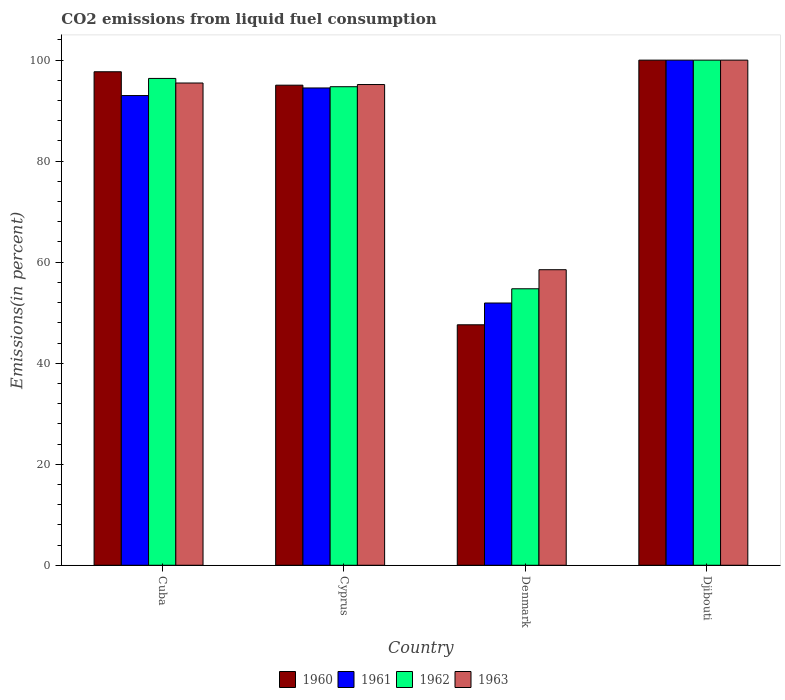How many different coloured bars are there?
Make the answer very short. 4. Are the number of bars on each tick of the X-axis equal?
Keep it short and to the point. Yes. How many bars are there on the 4th tick from the left?
Offer a very short reply. 4. How many bars are there on the 3rd tick from the right?
Your answer should be very brief. 4. What is the label of the 4th group of bars from the left?
Provide a succinct answer. Djibouti. Across all countries, what is the minimum total CO2 emitted in 1961?
Give a very brief answer. 51.92. In which country was the total CO2 emitted in 1961 maximum?
Offer a terse response. Djibouti. What is the total total CO2 emitted in 1960 in the graph?
Ensure brevity in your answer.  340.34. What is the difference between the total CO2 emitted in 1961 in Cyprus and that in Djibouti?
Give a very brief answer. -5.51. What is the difference between the total CO2 emitted in 1961 in Denmark and the total CO2 emitted in 1960 in Cuba?
Give a very brief answer. -45.78. What is the average total CO2 emitted in 1961 per country?
Offer a very short reply. 84.85. What is the difference between the total CO2 emitted of/in 1960 and total CO2 emitted of/in 1961 in Denmark?
Give a very brief answer. -4.31. In how many countries, is the total CO2 emitted in 1960 greater than 48 %?
Your answer should be compact. 3. What is the ratio of the total CO2 emitted in 1961 in Cuba to that in Djibouti?
Your answer should be compact. 0.93. Is the total CO2 emitted in 1963 in Cyprus less than that in Denmark?
Offer a very short reply. No. Is the difference between the total CO2 emitted in 1960 in Cyprus and Denmark greater than the difference between the total CO2 emitted in 1961 in Cyprus and Denmark?
Provide a short and direct response. Yes. What is the difference between the highest and the second highest total CO2 emitted in 1960?
Keep it short and to the point. -2.3. What is the difference between the highest and the lowest total CO2 emitted in 1962?
Offer a terse response. 45.26. Is it the case that in every country, the sum of the total CO2 emitted in 1960 and total CO2 emitted in 1963 is greater than the sum of total CO2 emitted in 1961 and total CO2 emitted in 1962?
Your response must be concise. No. What does the 1st bar from the left in Cyprus represents?
Provide a short and direct response. 1960. Is it the case that in every country, the sum of the total CO2 emitted in 1960 and total CO2 emitted in 1962 is greater than the total CO2 emitted in 1961?
Your answer should be compact. Yes. How many bars are there?
Provide a short and direct response. 16. How many countries are there in the graph?
Ensure brevity in your answer.  4. Are the values on the major ticks of Y-axis written in scientific E-notation?
Offer a very short reply. No. Does the graph contain grids?
Provide a short and direct response. No. Where does the legend appear in the graph?
Ensure brevity in your answer.  Bottom center. How many legend labels are there?
Offer a terse response. 4. How are the legend labels stacked?
Offer a terse response. Horizontal. What is the title of the graph?
Keep it short and to the point. CO2 emissions from liquid fuel consumption. What is the label or title of the X-axis?
Keep it short and to the point. Country. What is the label or title of the Y-axis?
Provide a succinct answer. Emissions(in percent). What is the Emissions(in percent) in 1960 in Cuba?
Provide a short and direct response. 97.7. What is the Emissions(in percent) of 1961 in Cuba?
Your response must be concise. 92.99. What is the Emissions(in percent) of 1962 in Cuba?
Make the answer very short. 96.38. What is the Emissions(in percent) of 1963 in Cuba?
Make the answer very short. 95.47. What is the Emissions(in percent) of 1960 in Cyprus?
Provide a short and direct response. 95.04. What is the Emissions(in percent) of 1961 in Cyprus?
Your response must be concise. 94.49. What is the Emissions(in percent) of 1962 in Cyprus?
Your answer should be compact. 94.74. What is the Emissions(in percent) in 1963 in Cyprus?
Make the answer very short. 95.17. What is the Emissions(in percent) in 1960 in Denmark?
Provide a succinct answer. 47.6. What is the Emissions(in percent) of 1961 in Denmark?
Make the answer very short. 51.92. What is the Emissions(in percent) in 1962 in Denmark?
Provide a short and direct response. 54.74. What is the Emissions(in percent) in 1963 in Denmark?
Ensure brevity in your answer.  58.51. What is the Emissions(in percent) in 1961 in Djibouti?
Your answer should be compact. 100. What is the Emissions(in percent) in 1962 in Djibouti?
Offer a very short reply. 100. What is the Emissions(in percent) in 1963 in Djibouti?
Offer a terse response. 100. Across all countries, what is the maximum Emissions(in percent) of 1963?
Your answer should be compact. 100. Across all countries, what is the minimum Emissions(in percent) in 1960?
Provide a succinct answer. 47.6. Across all countries, what is the minimum Emissions(in percent) of 1961?
Offer a terse response. 51.92. Across all countries, what is the minimum Emissions(in percent) of 1962?
Your response must be concise. 54.74. Across all countries, what is the minimum Emissions(in percent) of 1963?
Your answer should be very brief. 58.51. What is the total Emissions(in percent) in 1960 in the graph?
Provide a short and direct response. 340.34. What is the total Emissions(in percent) in 1961 in the graph?
Ensure brevity in your answer.  339.4. What is the total Emissions(in percent) in 1962 in the graph?
Make the answer very short. 345.85. What is the total Emissions(in percent) in 1963 in the graph?
Your response must be concise. 349.15. What is the difference between the Emissions(in percent) of 1960 in Cuba and that in Cyprus?
Give a very brief answer. 2.66. What is the difference between the Emissions(in percent) of 1961 in Cuba and that in Cyprus?
Your answer should be compact. -1.51. What is the difference between the Emissions(in percent) of 1962 in Cuba and that in Cyprus?
Offer a terse response. 1.64. What is the difference between the Emissions(in percent) in 1963 in Cuba and that in Cyprus?
Provide a short and direct response. 0.31. What is the difference between the Emissions(in percent) of 1960 in Cuba and that in Denmark?
Make the answer very short. 50.09. What is the difference between the Emissions(in percent) of 1961 in Cuba and that in Denmark?
Give a very brief answer. 41.07. What is the difference between the Emissions(in percent) in 1962 in Cuba and that in Denmark?
Your response must be concise. 41.64. What is the difference between the Emissions(in percent) of 1963 in Cuba and that in Denmark?
Offer a terse response. 36.96. What is the difference between the Emissions(in percent) of 1960 in Cuba and that in Djibouti?
Keep it short and to the point. -2.3. What is the difference between the Emissions(in percent) of 1961 in Cuba and that in Djibouti?
Make the answer very short. -7.01. What is the difference between the Emissions(in percent) in 1962 in Cuba and that in Djibouti?
Offer a terse response. -3.62. What is the difference between the Emissions(in percent) of 1963 in Cuba and that in Djibouti?
Offer a very short reply. -4.53. What is the difference between the Emissions(in percent) in 1960 in Cyprus and that in Denmark?
Ensure brevity in your answer.  47.44. What is the difference between the Emissions(in percent) in 1961 in Cyprus and that in Denmark?
Keep it short and to the point. 42.57. What is the difference between the Emissions(in percent) in 1963 in Cyprus and that in Denmark?
Your answer should be very brief. 36.66. What is the difference between the Emissions(in percent) in 1960 in Cyprus and that in Djibouti?
Your answer should be very brief. -4.96. What is the difference between the Emissions(in percent) of 1961 in Cyprus and that in Djibouti?
Your answer should be compact. -5.51. What is the difference between the Emissions(in percent) in 1962 in Cyprus and that in Djibouti?
Offer a very short reply. -5.26. What is the difference between the Emissions(in percent) in 1963 in Cyprus and that in Djibouti?
Your answer should be compact. -4.83. What is the difference between the Emissions(in percent) in 1960 in Denmark and that in Djibouti?
Keep it short and to the point. -52.4. What is the difference between the Emissions(in percent) in 1961 in Denmark and that in Djibouti?
Offer a very short reply. -48.08. What is the difference between the Emissions(in percent) of 1962 in Denmark and that in Djibouti?
Your answer should be very brief. -45.26. What is the difference between the Emissions(in percent) of 1963 in Denmark and that in Djibouti?
Offer a very short reply. -41.49. What is the difference between the Emissions(in percent) of 1960 in Cuba and the Emissions(in percent) of 1961 in Cyprus?
Keep it short and to the point. 3.21. What is the difference between the Emissions(in percent) of 1960 in Cuba and the Emissions(in percent) of 1962 in Cyprus?
Your answer should be compact. 2.96. What is the difference between the Emissions(in percent) of 1960 in Cuba and the Emissions(in percent) of 1963 in Cyprus?
Make the answer very short. 2.53. What is the difference between the Emissions(in percent) in 1961 in Cuba and the Emissions(in percent) in 1962 in Cyprus?
Provide a short and direct response. -1.75. What is the difference between the Emissions(in percent) of 1961 in Cuba and the Emissions(in percent) of 1963 in Cyprus?
Make the answer very short. -2.18. What is the difference between the Emissions(in percent) of 1962 in Cuba and the Emissions(in percent) of 1963 in Cyprus?
Your response must be concise. 1.21. What is the difference between the Emissions(in percent) of 1960 in Cuba and the Emissions(in percent) of 1961 in Denmark?
Your answer should be compact. 45.78. What is the difference between the Emissions(in percent) in 1960 in Cuba and the Emissions(in percent) in 1962 in Denmark?
Ensure brevity in your answer.  42.96. What is the difference between the Emissions(in percent) in 1960 in Cuba and the Emissions(in percent) in 1963 in Denmark?
Your answer should be very brief. 39.19. What is the difference between the Emissions(in percent) of 1961 in Cuba and the Emissions(in percent) of 1962 in Denmark?
Offer a very short reply. 38.25. What is the difference between the Emissions(in percent) of 1961 in Cuba and the Emissions(in percent) of 1963 in Denmark?
Offer a very short reply. 34.48. What is the difference between the Emissions(in percent) in 1962 in Cuba and the Emissions(in percent) in 1963 in Denmark?
Provide a succinct answer. 37.87. What is the difference between the Emissions(in percent) of 1960 in Cuba and the Emissions(in percent) of 1961 in Djibouti?
Make the answer very short. -2.3. What is the difference between the Emissions(in percent) of 1960 in Cuba and the Emissions(in percent) of 1962 in Djibouti?
Make the answer very short. -2.3. What is the difference between the Emissions(in percent) of 1960 in Cuba and the Emissions(in percent) of 1963 in Djibouti?
Make the answer very short. -2.3. What is the difference between the Emissions(in percent) of 1961 in Cuba and the Emissions(in percent) of 1962 in Djibouti?
Provide a succinct answer. -7.01. What is the difference between the Emissions(in percent) of 1961 in Cuba and the Emissions(in percent) of 1963 in Djibouti?
Keep it short and to the point. -7.01. What is the difference between the Emissions(in percent) in 1962 in Cuba and the Emissions(in percent) in 1963 in Djibouti?
Make the answer very short. -3.62. What is the difference between the Emissions(in percent) in 1960 in Cyprus and the Emissions(in percent) in 1961 in Denmark?
Provide a short and direct response. 43.12. What is the difference between the Emissions(in percent) of 1960 in Cyprus and the Emissions(in percent) of 1962 in Denmark?
Keep it short and to the point. 40.3. What is the difference between the Emissions(in percent) in 1960 in Cyprus and the Emissions(in percent) in 1963 in Denmark?
Ensure brevity in your answer.  36.53. What is the difference between the Emissions(in percent) in 1961 in Cyprus and the Emissions(in percent) in 1962 in Denmark?
Provide a succinct answer. 39.75. What is the difference between the Emissions(in percent) in 1961 in Cyprus and the Emissions(in percent) in 1963 in Denmark?
Your answer should be compact. 35.98. What is the difference between the Emissions(in percent) in 1962 in Cyprus and the Emissions(in percent) in 1963 in Denmark?
Your answer should be very brief. 36.23. What is the difference between the Emissions(in percent) of 1960 in Cyprus and the Emissions(in percent) of 1961 in Djibouti?
Provide a short and direct response. -4.96. What is the difference between the Emissions(in percent) in 1960 in Cyprus and the Emissions(in percent) in 1962 in Djibouti?
Give a very brief answer. -4.96. What is the difference between the Emissions(in percent) of 1960 in Cyprus and the Emissions(in percent) of 1963 in Djibouti?
Your response must be concise. -4.96. What is the difference between the Emissions(in percent) in 1961 in Cyprus and the Emissions(in percent) in 1962 in Djibouti?
Offer a terse response. -5.51. What is the difference between the Emissions(in percent) in 1961 in Cyprus and the Emissions(in percent) in 1963 in Djibouti?
Provide a short and direct response. -5.51. What is the difference between the Emissions(in percent) in 1962 in Cyprus and the Emissions(in percent) in 1963 in Djibouti?
Provide a short and direct response. -5.26. What is the difference between the Emissions(in percent) of 1960 in Denmark and the Emissions(in percent) of 1961 in Djibouti?
Provide a short and direct response. -52.4. What is the difference between the Emissions(in percent) of 1960 in Denmark and the Emissions(in percent) of 1962 in Djibouti?
Your answer should be compact. -52.4. What is the difference between the Emissions(in percent) of 1960 in Denmark and the Emissions(in percent) of 1963 in Djibouti?
Keep it short and to the point. -52.4. What is the difference between the Emissions(in percent) in 1961 in Denmark and the Emissions(in percent) in 1962 in Djibouti?
Make the answer very short. -48.08. What is the difference between the Emissions(in percent) of 1961 in Denmark and the Emissions(in percent) of 1963 in Djibouti?
Offer a terse response. -48.08. What is the difference between the Emissions(in percent) of 1962 in Denmark and the Emissions(in percent) of 1963 in Djibouti?
Your answer should be compact. -45.26. What is the average Emissions(in percent) of 1960 per country?
Your answer should be compact. 85.09. What is the average Emissions(in percent) in 1961 per country?
Give a very brief answer. 84.85. What is the average Emissions(in percent) in 1962 per country?
Your answer should be compact. 86.46. What is the average Emissions(in percent) of 1963 per country?
Your answer should be compact. 87.29. What is the difference between the Emissions(in percent) of 1960 and Emissions(in percent) of 1961 in Cuba?
Your answer should be compact. 4.71. What is the difference between the Emissions(in percent) of 1960 and Emissions(in percent) of 1962 in Cuba?
Provide a succinct answer. 1.32. What is the difference between the Emissions(in percent) of 1960 and Emissions(in percent) of 1963 in Cuba?
Offer a terse response. 2.23. What is the difference between the Emissions(in percent) of 1961 and Emissions(in percent) of 1962 in Cuba?
Provide a succinct answer. -3.39. What is the difference between the Emissions(in percent) of 1961 and Emissions(in percent) of 1963 in Cuba?
Offer a very short reply. -2.49. What is the difference between the Emissions(in percent) of 1962 and Emissions(in percent) of 1963 in Cuba?
Your answer should be very brief. 0.9. What is the difference between the Emissions(in percent) of 1960 and Emissions(in percent) of 1961 in Cyprus?
Provide a short and direct response. 0.55. What is the difference between the Emissions(in percent) in 1960 and Emissions(in percent) in 1962 in Cyprus?
Provide a succinct answer. 0.3. What is the difference between the Emissions(in percent) in 1960 and Emissions(in percent) in 1963 in Cyprus?
Your answer should be very brief. -0.13. What is the difference between the Emissions(in percent) of 1961 and Emissions(in percent) of 1962 in Cyprus?
Ensure brevity in your answer.  -0.25. What is the difference between the Emissions(in percent) of 1961 and Emissions(in percent) of 1963 in Cyprus?
Give a very brief answer. -0.68. What is the difference between the Emissions(in percent) in 1962 and Emissions(in percent) in 1963 in Cyprus?
Give a very brief answer. -0.43. What is the difference between the Emissions(in percent) in 1960 and Emissions(in percent) in 1961 in Denmark?
Offer a very short reply. -4.31. What is the difference between the Emissions(in percent) of 1960 and Emissions(in percent) of 1962 in Denmark?
Make the answer very short. -7.13. What is the difference between the Emissions(in percent) in 1960 and Emissions(in percent) in 1963 in Denmark?
Provide a short and direct response. -10.9. What is the difference between the Emissions(in percent) in 1961 and Emissions(in percent) in 1962 in Denmark?
Your answer should be compact. -2.82. What is the difference between the Emissions(in percent) in 1961 and Emissions(in percent) in 1963 in Denmark?
Ensure brevity in your answer.  -6.59. What is the difference between the Emissions(in percent) in 1962 and Emissions(in percent) in 1963 in Denmark?
Provide a short and direct response. -3.77. What is the difference between the Emissions(in percent) in 1960 and Emissions(in percent) in 1961 in Djibouti?
Your response must be concise. 0. What is the difference between the Emissions(in percent) of 1961 and Emissions(in percent) of 1962 in Djibouti?
Your answer should be compact. 0. What is the difference between the Emissions(in percent) of 1961 and Emissions(in percent) of 1963 in Djibouti?
Your answer should be very brief. 0. What is the ratio of the Emissions(in percent) in 1960 in Cuba to that in Cyprus?
Offer a terse response. 1.03. What is the ratio of the Emissions(in percent) of 1961 in Cuba to that in Cyprus?
Keep it short and to the point. 0.98. What is the ratio of the Emissions(in percent) in 1962 in Cuba to that in Cyprus?
Your answer should be very brief. 1.02. What is the ratio of the Emissions(in percent) in 1960 in Cuba to that in Denmark?
Your response must be concise. 2.05. What is the ratio of the Emissions(in percent) of 1961 in Cuba to that in Denmark?
Make the answer very short. 1.79. What is the ratio of the Emissions(in percent) of 1962 in Cuba to that in Denmark?
Give a very brief answer. 1.76. What is the ratio of the Emissions(in percent) of 1963 in Cuba to that in Denmark?
Provide a short and direct response. 1.63. What is the ratio of the Emissions(in percent) of 1961 in Cuba to that in Djibouti?
Ensure brevity in your answer.  0.93. What is the ratio of the Emissions(in percent) of 1962 in Cuba to that in Djibouti?
Your answer should be compact. 0.96. What is the ratio of the Emissions(in percent) in 1963 in Cuba to that in Djibouti?
Your response must be concise. 0.95. What is the ratio of the Emissions(in percent) of 1960 in Cyprus to that in Denmark?
Your answer should be compact. 2. What is the ratio of the Emissions(in percent) of 1961 in Cyprus to that in Denmark?
Your response must be concise. 1.82. What is the ratio of the Emissions(in percent) of 1962 in Cyprus to that in Denmark?
Offer a very short reply. 1.73. What is the ratio of the Emissions(in percent) of 1963 in Cyprus to that in Denmark?
Provide a short and direct response. 1.63. What is the ratio of the Emissions(in percent) of 1960 in Cyprus to that in Djibouti?
Your answer should be very brief. 0.95. What is the ratio of the Emissions(in percent) in 1961 in Cyprus to that in Djibouti?
Offer a terse response. 0.94. What is the ratio of the Emissions(in percent) of 1962 in Cyprus to that in Djibouti?
Give a very brief answer. 0.95. What is the ratio of the Emissions(in percent) in 1963 in Cyprus to that in Djibouti?
Keep it short and to the point. 0.95. What is the ratio of the Emissions(in percent) in 1960 in Denmark to that in Djibouti?
Provide a short and direct response. 0.48. What is the ratio of the Emissions(in percent) in 1961 in Denmark to that in Djibouti?
Your answer should be very brief. 0.52. What is the ratio of the Emissions(in percent) of 1962 in Denmark to that in Djibouti?
Your answer should be compact. 0.55. What is the ratio of the Emissions(in percent) in 1963 in Denmark to that in Djibouti?
Provide a succinct answer. 0.59. What is the difference between the highest and the second highest Emissions(in percent) of 1960?
Provide a short and direct response. 2.3. What is the difference between the highest and the second highest Emissions(in percent) of 1961?
Offer a very short reply. 5.51. What is the difference between the highest and the second highest Emissions(in percent) in 1962?
Your answer should be very brief. 3.62. What is the difference between the highest and the second highest Emissions(in percent) of 1963?
Ensure brevity in your answer.  4.53. What is the difference between the highest and the lowest Emissions(in percent) of 1960?
Give a very brief answer. 52.4. What is the difference between the highest and the lowest Emissions(in percent) of 1961?
Offer a terse response. 48.08. What is the difference between the highest and the lowest Emissions(in percent) of 1962?
Provide a succinct answer. 45.26. What is the difference between the highest and the lowest Emissions(in percent) in 1963?
Provide a short and direct response. 41.49. 